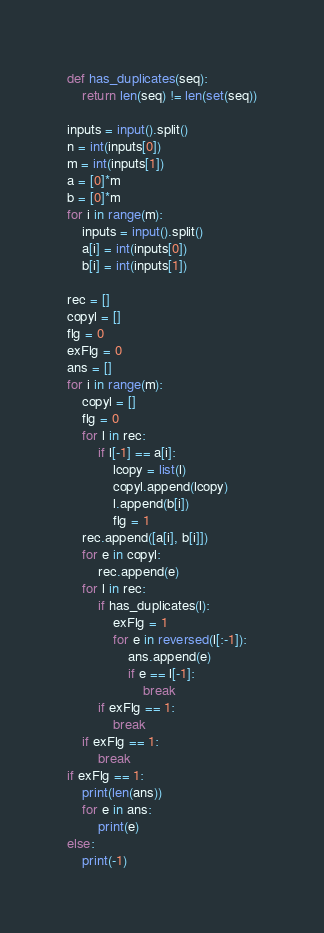<code> <loc_0><loc_0><loc_500><loc_500><_Python_>def has_duplicates(seq):
    return len(seq) != len(set(seq))

inputs = input().split()
n = int(inputs[0])
m = int(inputs[1])
a = [0]*m
b = [0]*m
for i in range(m):
    inputs = input().split()
    a[i] = int(inputs[0])
    b[i] = int(inputs[1])

rec = []
copyl = []
flg = 0
exFlg = 0
ans = []
for i in range(m):
    copyl = []
    flg = 0
    for l in rec:
        if l[-1] == a[i]:
            lcopy = list(l)
            copyl.append(lcopy)
            l.append(b[i])
            flg = 1
    rec.append([a[i], b[i]])
    for e in copyl:
        rec.append(e)
    for l in rec:
        if has_duplicates(l):
            exFlg = 1
            for e in reversed(l[:-1]):
                ans.append(e)
                if e == l[-1]:
                    break
        if exFlg == 1:
            break
    if exFlg == 1:
        break
if exFlg == 1:
    print(len(ans))
    for e in ans:
        print(e)
else:
    print(-1)
</code> 